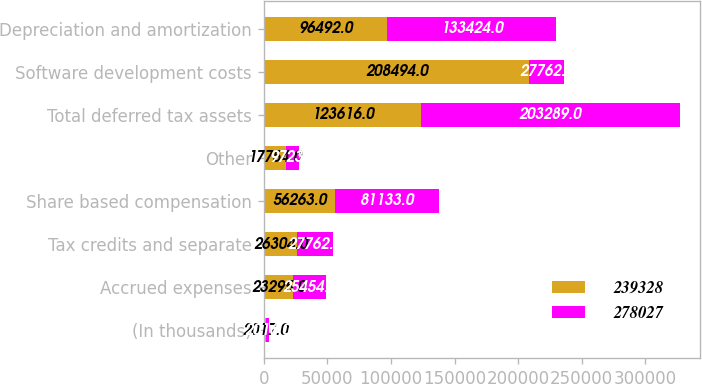<chart> <loc_0><loc_0><loc_500><loc_500><stacked_bar_chart><ecel><fcel>(In thousands)<fcel>Accrued expenses<fcel>Tax credits and separate<fcel>Share based compensation<fcel>Other<fcel>Total deferred tax assets<fcel>Software development costs<fcel>Depreciation and amortization<nl><fcel>239328<fcel>2017<fcel>23295<fcel>26304<fcel>56263<fcel>17754<fcel>123616<fcel>208494<fcel>96492<nl><fcel>278027<fcel>2016<fcel>25454<fcel>27762<fcel>81133<fcel>9723<fcel>203289<fcel>27762<fcel>133424<nl></chart> 